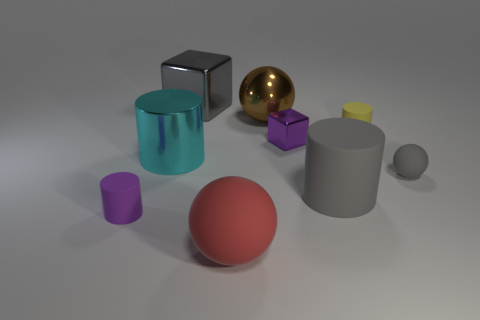There is a purple thing left of the gray shiny block; is it the same size as the metallic cube right of the red thing?
Keep it short and to the point. Yes. What number of other things are there of the same material as the big red thing
Keep it short and to the point. 4. Are there more large things in front of the big cube than red spheres in front of the large red rubber object?
Offer a terse response. Yes. There is a big gray thing that is on the left side of the large rubber cylinder; what is it made of?
Offer a terse response. Metal. Is the shape of the small metallic thing the same as the big red object?
Provide a short and direct response. No. Is there any other thing that is the same color as the shiny ball?
Ensure brevity in your answer.  No. What color is the other tiny object that is the same shape as the yellow matte thing?
Make the answer very short. Purple. Is the number of cylinders in front of the small yellow matte cylinder greater than the number of yellow things?
Make the answer very short. Yes. There is a matte cylinder behind the large cyan metallic cylinder; what color is it?
Provide a short and direct response. Yellow. Is the size of the purple matte thing the same as the metallic cylinder?
Give a very brief answer. No. 